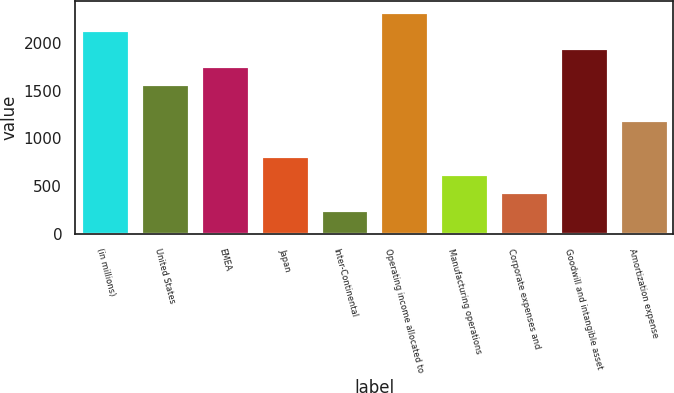Convert chart to OTSL. <chart><loc_0><loc_0><loc_500><loc_500><bar_chart><fcel>(in millions)<fcel>United States<fcel>EMEA<fcel>Japan<fcel>Inter-Continental<fcel>Operating income allocated to<fcel>Manufacturing operations<fcel>Corporate expenses and<fcel>Goodwill and intangible asset<fcel>Amortization expense<nl><fcel>2135<fcel>1569.5<fcel>1758<fcel>815.5<fcel>250<fcel>2323.5<fcel>627<fcel>438.5<fcel>1946.5<fcel>1192.5<nl></chart> 